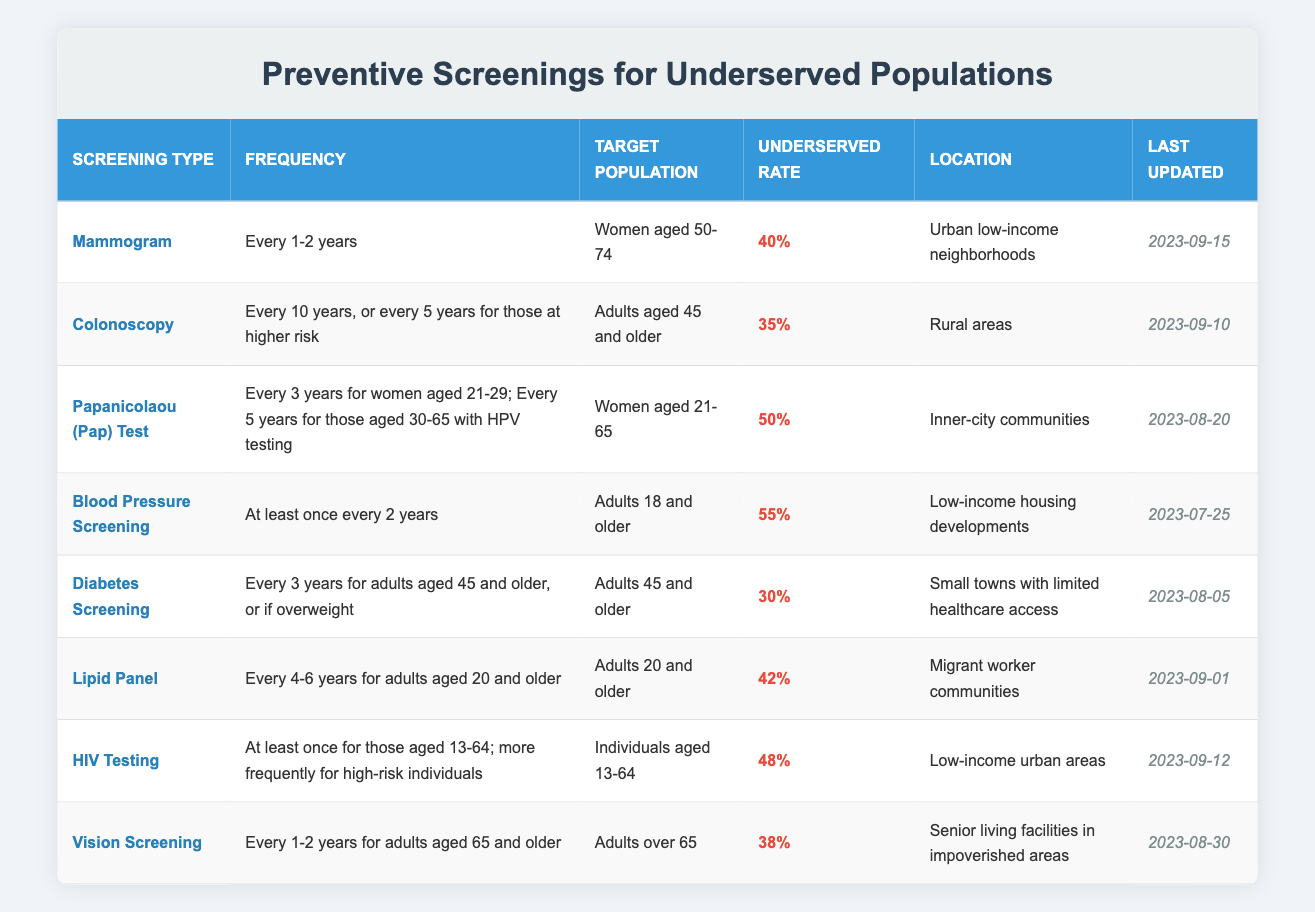What is the underserved rate for Blood Pressure Screening? The table lists an underserved rate column where Blood Pressure Screening is noted. Looking at that specific row, the underserved rate is shown as 55%.
Answer: 55% Which screening requires women aged 50-74 to be screened every 1-2 years? In the table under Screening Type, a screening specifically mentions the target population being women aged 50-74 with a frequency of "Every 1-2 years". This corresponds to Mammogram.
Answer: Mammogram How many years must pass between each Diabetes Screening for adults aged 45 and older? The table specifies that for adults aged 45 and older, Diabetes Screening should occur every 3 years. This is stated directly in the frequency column.
Answer: Every 3 years Is the last update for Lipid Panel screening more recent than that for Papanicolaou (Pap) Test? To answer this, we check the "Last Updated" column for both screenings: Lipid Panel was last updated on 2023-09-01 and Papanicolaou (Pap) Test was last updated on 2023-08-20. Since September is after August, Lipid Panel has been updated more recently.
Answer: Yes What percentage of adults aged 20 and older fall under underserved rates for Lipid Panel screening? The underserved rate listed in the Lipid Panel row states 42%. This value is taken directly from the table.
Answer: 42% How frequently should individuals aged 13-64 have HIV Testing? The frequency for HIV Testing as stated in the table is at least once for individuals aged 13-64, and more often for those at high risk. This information is found within the corresponding row.
Answer: At least once What is the average underserved rate for all screenings listed in the table? To calculate the average underserved rate, first, the individual rates must be summed: 40 + 35 + 50 + 55 + 30 + 42 + 48 + 38 = 338. There are 8 screenings in total, so the average is 338 / 8 = 42.25.
Answer: 42.25 Which location has the lowest underserved rate for preventive screenings, and what is that rate? By inspecting the table, the lowest underserved rate is observed for Diabetes Screening located in small towns with limited healthcare access, with a rate of 30%.
Answer: 30% 